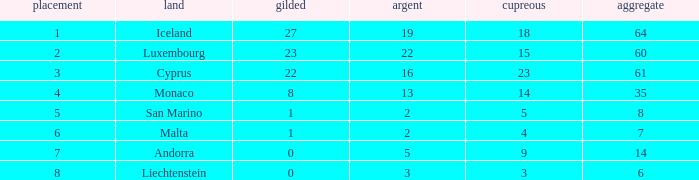How many bronzes for nations with over 22 golds and ranked under 2? 18.0. 